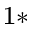Convert formula to latex. <formula><loc_0><loc_0><loc_500><loc_500>^ { 1 \ast }</formula> 